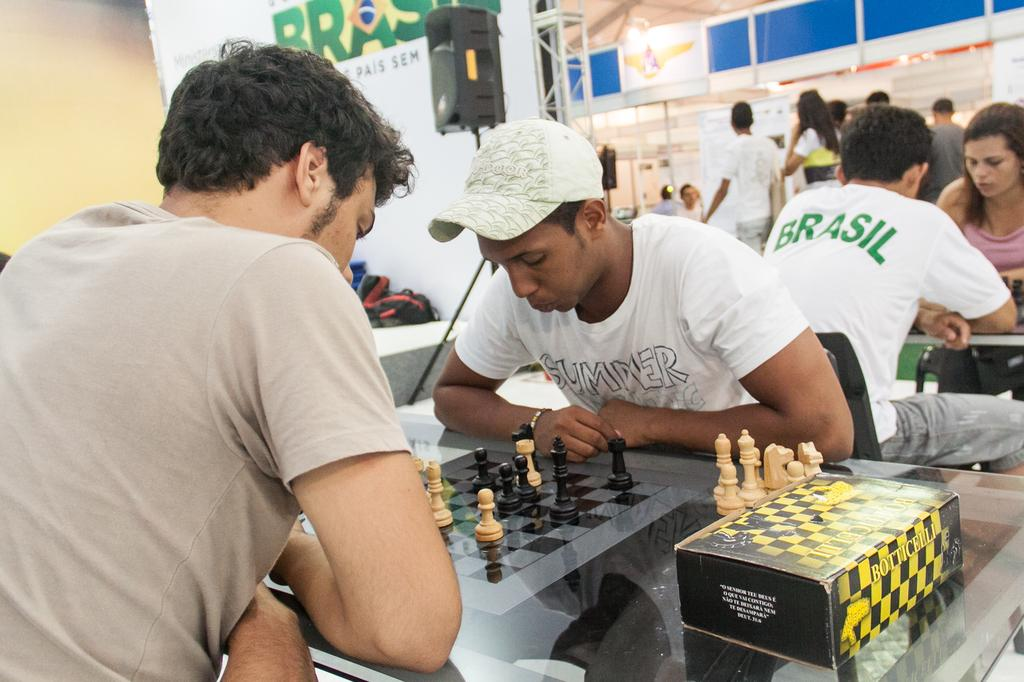<image>
Provide a brief description of the given image. Two men are playing a game of chess in Brazil. 